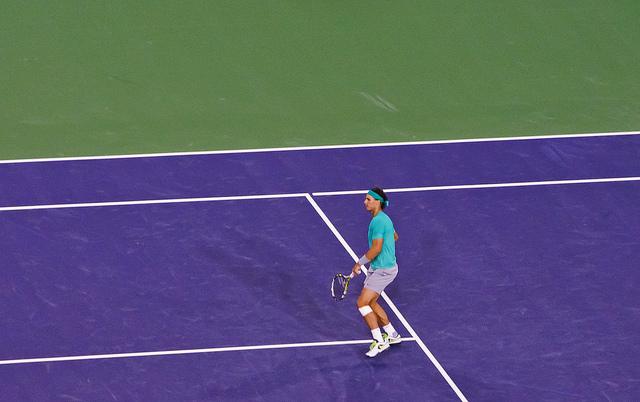What hand does this player write with?
Write a very short answer. Left. What is the player preparing to do?
Answer briefly. Serve. Is the camera level with the player?
Short answer required. No. What sport is he playing?
Write a very short answer. Tennis. 